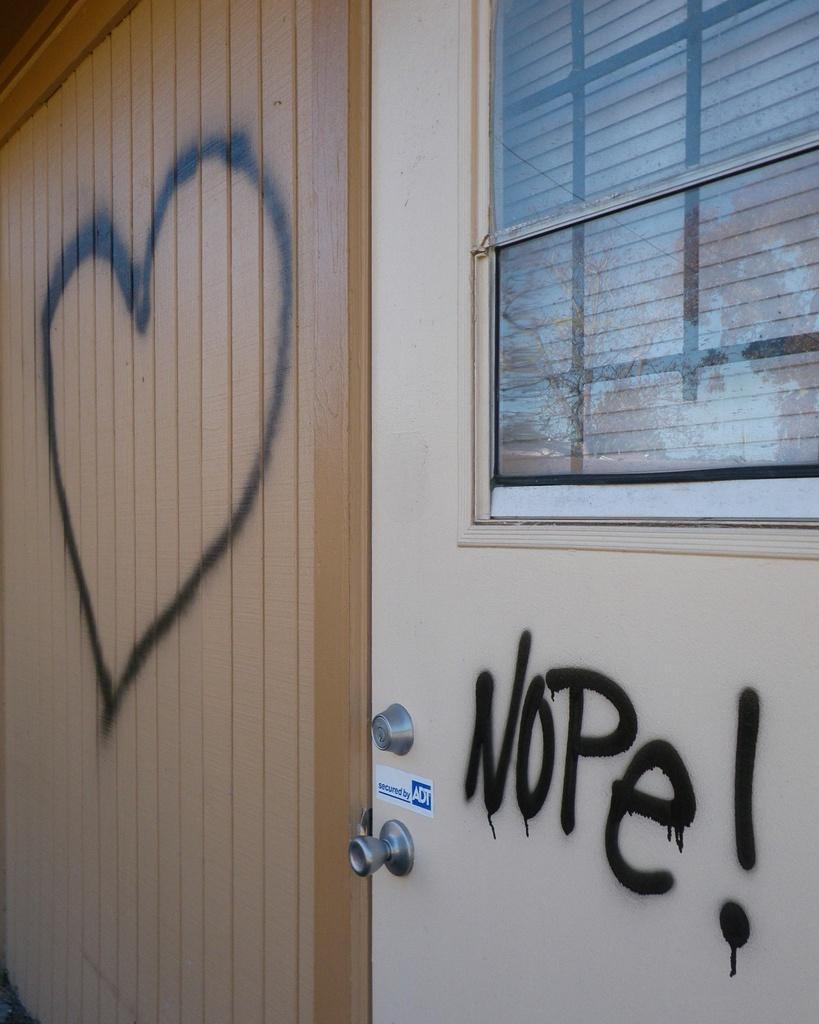Describe this image in one or two sentences. In the center of the image there is a door and we can see a window. On the left there is a wall and we can see a graffiti on the wall. 